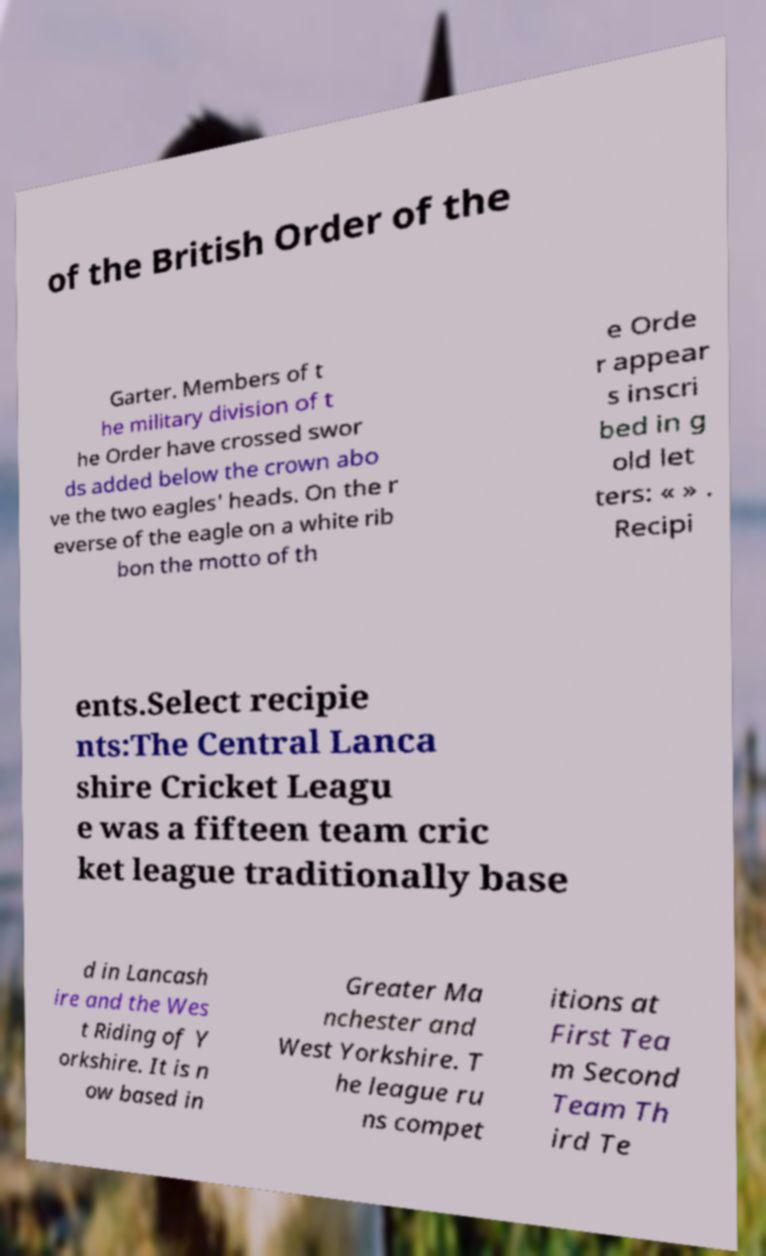Could you extract and type out the text from this image? of the British Order of the Garter. Members of t he military division of t he Order have crossed swor ds added below the crown abo ve the two eagles' heads. On the r everse of the eagle on a white rib bon the motto of th e Orde r appear s inscri bed in g old let ters: « » . Recipi ents.Select recipie nts:The Central Lanca shire Cricket Leagu e was a fifteen team cric ket league traditionally base d in Lancash ire and the Wes t Riding of Y orkshire. It is n ow based in Greater Ma nchester and West Yorkshire. T he league ru ns compet itions at First Tea m Second Team Th ird Te 